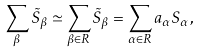<formula> <loc_0><loc_0><loc_500><loc_500>\sum _ { \beta } \tilde { S } _ { \beta } \simeq \sum _ { \beta \in R } \tilde { S } _ { \beta } = \sum _ { \alpha \in R } a _ { \alpha } S _ { \alpha } ,</formula> 